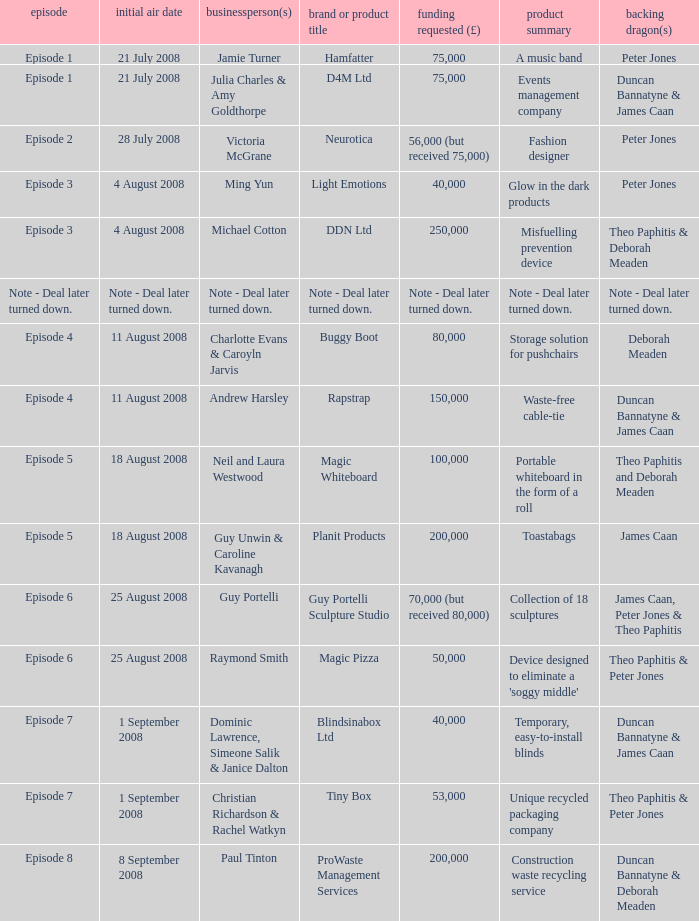Who is the company Investing Dragons, or tiny box? Theo Paphitis & Peter Jones. I'm looking to parse the entire table for insights. Could you assist me with that? {'header': ['episode', 'initial air date', 'businessperson(s)', 'brand or product title', 'funding requested (£)', 'product summary', 'backing dragon(s)'], 'rows': [['Episode 1', '21 July 2008', 'Jamie Turner', 'Hamfatter', '75,000', 'A music band', 'Peter Jones'], ['Episode 1', '21 July 2008', 'Julia Charles & Amy Goldthorpe', 'D4M Ltd', '75,000', 'Events management company', 'Duncan Bannatyne & James Caan'], ['Episode 2', '28 July 2008', 'Victoria McGrane', 'Neurotica', '56,000 (but received 75,000)', 'Fashion designer', 'Peter Jones'], ['Episode 3', '4 August 2008', 'Ming Yun', 'Light Emotions', '40,000', 'Glow in the dark products', 'Peter Jones'], ['Episode 3', '4 August 2008', 'Michael Cotton', 'DDN Ltd', '250,000', 'Misfuelling prevention device', 'Theo Paphitis & Deborah Meaden'], ['Note - Deal later turned down.', 'Note - Deal later turned down.', 'Note - Deal later turned down.', 'Note - Deal later turned down.', 'Note - Deal later turned down.', 'Note - Deal later turned down.', 'Note - Deal later turned down.'], ['Episode 4', '11 August 2008', 'Charlotte Evans & Caroyln Jarvis', 'Buggy Boot', '80,000', 'Storage solution for pushchairs', 'Deborah Meaden'], ['Episode 4', '11 August 2008', 'Andrew Harsley', 'Rapstrap', '150,000', 'Waste-free cable-tie', 'Duncan Bannatyne & James Caan'], ['Episode 5', '18 August 2008', 'Neil and Laura Westwood', 'Magic Whiteboard', '100,000', 'Portable whiteboard in the form of a roll', 'Theo Paphitis and Deborah Meaden'], ['Episode 5', '18 August 2008', 'Guy Unwin & Caroline Kavanagh', 'Planit Products', '200,000', 'Toastabags', 'James Caan'], ['Episode 6', '25 August 2008', 'Guy Portelli', 'Guy Portelli Sculpture Studio', '70,000 (but received 80,000)', 'Collection of 18 sculptures', 'James Caan, Peter Jones & Theo Paphitis'], ['Episode 6', '25 August 2008', 'Raymond Smith', 'Magic Pizza', '50,000', "Device designed to eliminate a 'soggy middle'", 'Theo Paphitis & Peter Jones'], ['Episode 7', '1 September 2008', 'Dominic Lawrence, Simeone Salik & Janice Dalton', 'Blindsinabox Ltd', '40,000', 'Temporary, easy-to-install blinds', 'Duncan Bannatyne & James Caan'], ['Episode 7', '1 September 2008', 'Christian Richardson & Rachel Watkyn', 'Tiny Box', '53,000', 'Unique recycled packaging company', 'Theo Paphitis & Peter Jones'], ['Episode 8', '8 September 2008', 'Paul Tinton', 'ProWaste Management Services', '200,000', 'Construction waste recycling service', 'Duncan Bannatyne & Deborah Meaden']]} 